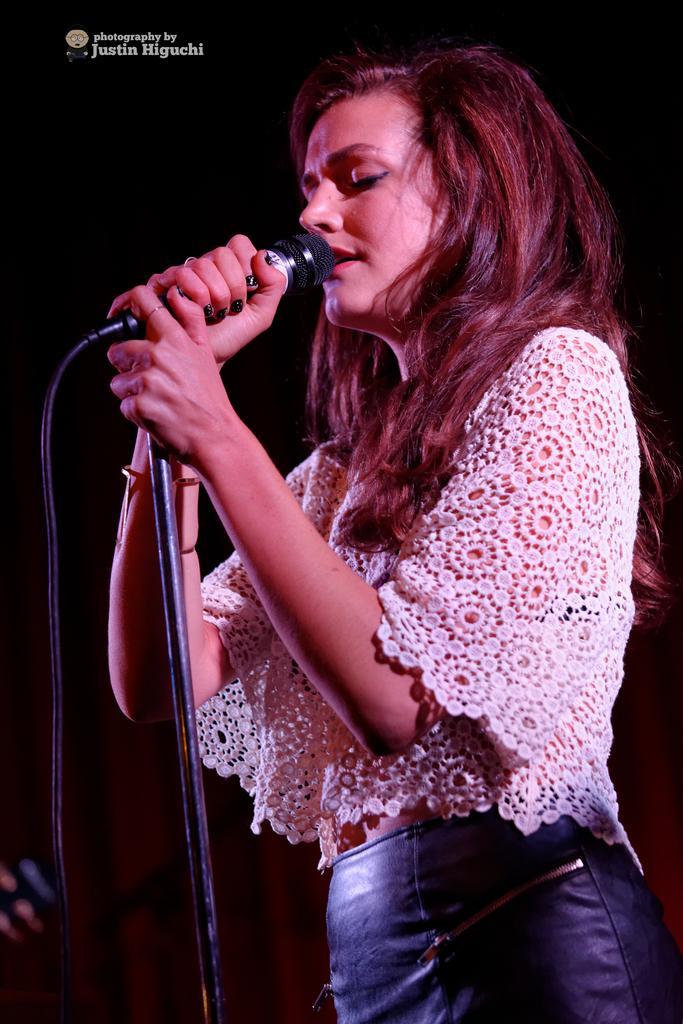Can you describe this image briefly? In this image i can see a woman standing and singing in front of a microphone, she is wearing a white shirt and blue jeans. 